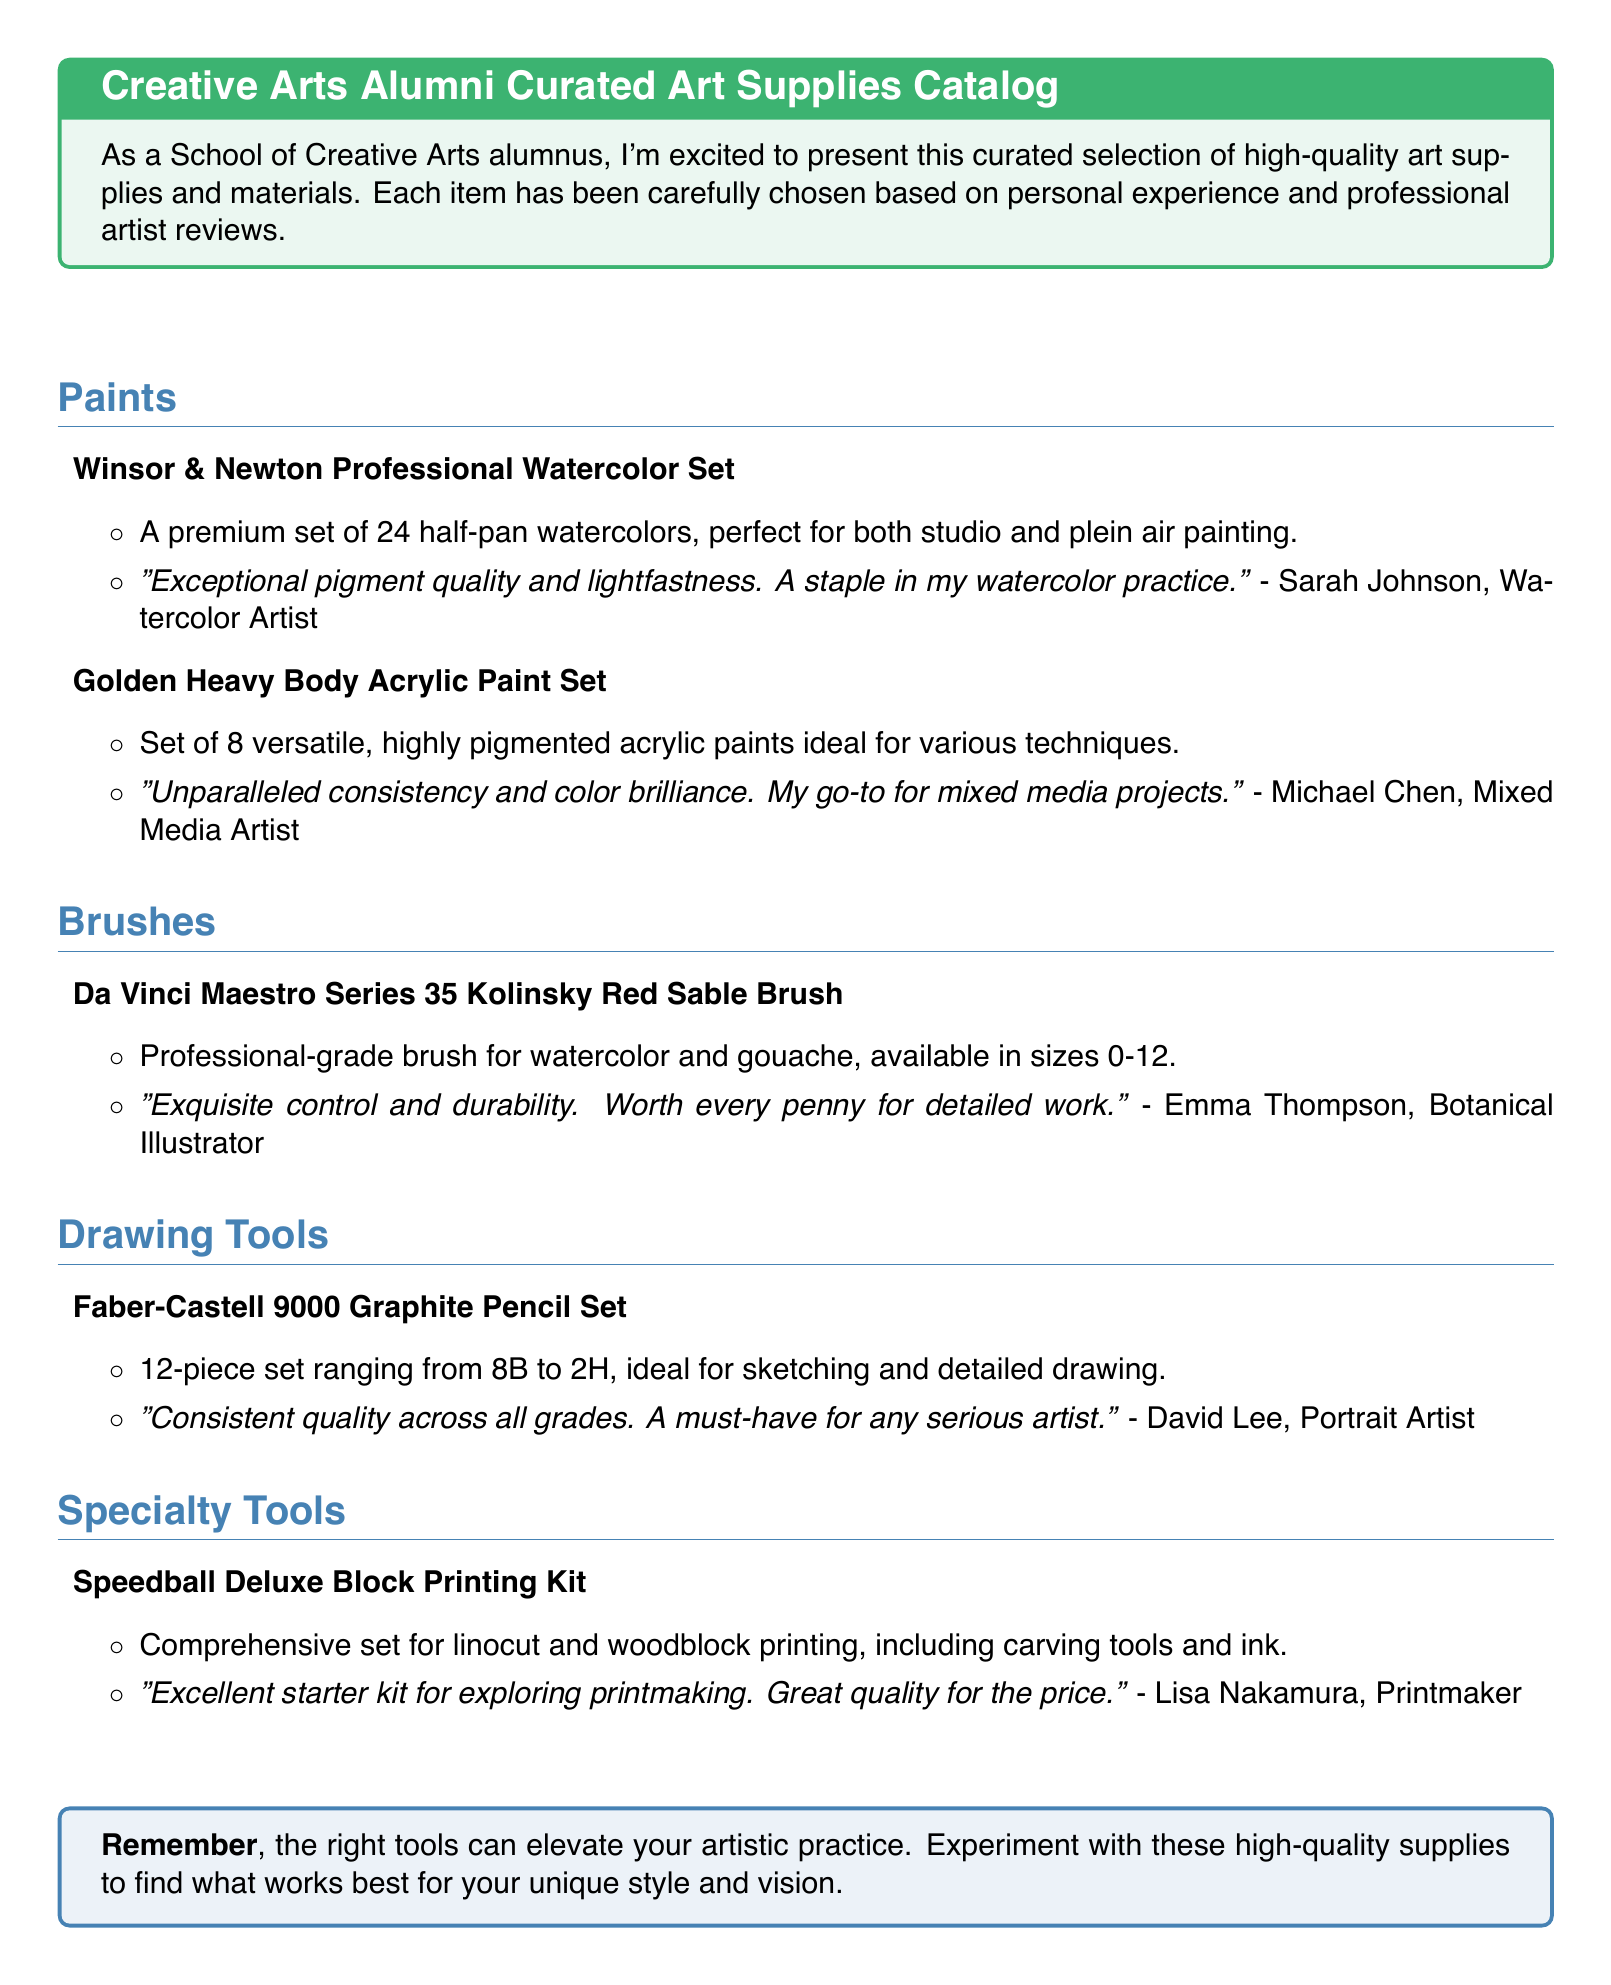What is the title of the catalog? The title is stated in the introductory box at the beginning of the document, which is "Creative Arts Alumni Curated Art Supplies Catalog."
Answer: Creative Arts Alumni Curated Art Supplies Catalog How many paints are listed in the catalog? The catalog includes two specific paint products listed under the "Paints" section.
Answer: 2 What product is recommended for detailed work? The recommendation for detailed work is found under the "Brushes" section, specifically mentioning a professional-grade brush.
Answer: Da Vinci Maestro Series 35 Kolinsky Red Sable Brush Who provided the review for the Golden Heavy Body Acrylic Paint Set? The review is attributed to a mixed media artist named Michael Chen, who shared his thoughts on this paint set.
Answer: Michael Chen What specialty tool kit is mentioned for printmaking? The document lists a specific kit designed for printmaking in the "Specialty Tools" section.
Answer: Speedball Deluxe Block Printing Kit Which artist specializes in botanical illustration? The name of the artist who focuses on botanical illustration is mentioned in the review of a specific brush.
Answer: Emma Thompson How many pieces are in the Faber-Castell 9000 Graphite Pencil Set? The pencil set is described in the drawing tools section, indicating the number of pieces included.
Answer: 12 What color descriptor is used for the outline of the title section? The color mentioned for the outline of the title section is provided in the formatting section of the catalog.
Answer: artblue 